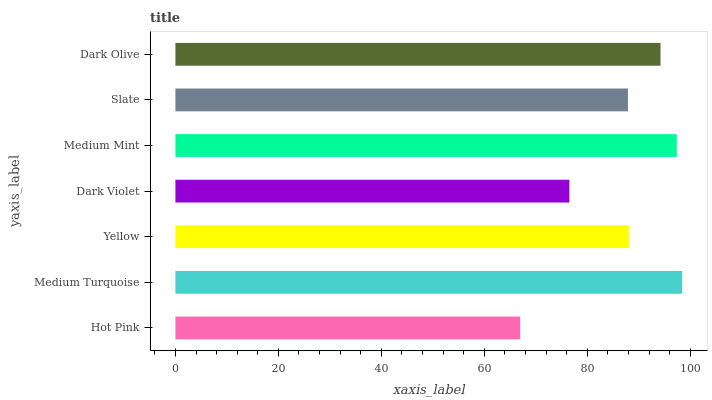Is Hot Pink the minimum?
Answer yes or no. Yes. Is Medium Turquoise the maximum?
Answer yes or no. Yes. Is Yellow the minimum?
Answer yes or no. No. Is Yellow the maximum?
Answer yes or no. No. Is Medium Turquoise greater than Yellow?
Answer yes or no. Yes. Is Yellow less than Medium Turquoise?
Answer yes or no. Yes. Is Yellow greater than Medium Turquoise?
Answer yes or no. No. Is Medium Turquoise less than Yellow?
Answer yes or no. No. Is Yellow the high median?
Answer yes or no. Yes. Is Yellow the low median?
Answer yes or no. Yes. Is Dark Olive the high median?
Answer yes or no. No. Is Medium Mint the low median?
Answer yes or no. No. 